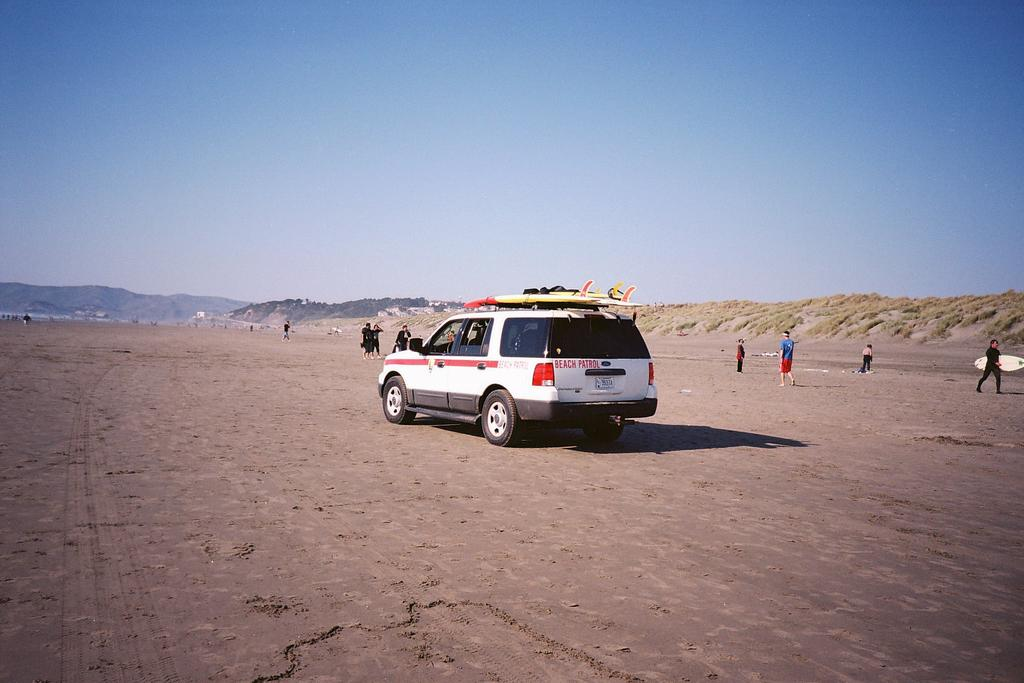What is the main subject of the image? There is a vehicle in the image. What are the people on the ground doing? One person is holding a surfboard. What can be seen in the background of the image? There are mountains and the sky visible in the background of the image. What flavor of straw is being used by the person holding the surfboard? There is no straw present in the image, and therefore no flavor can be determined. 